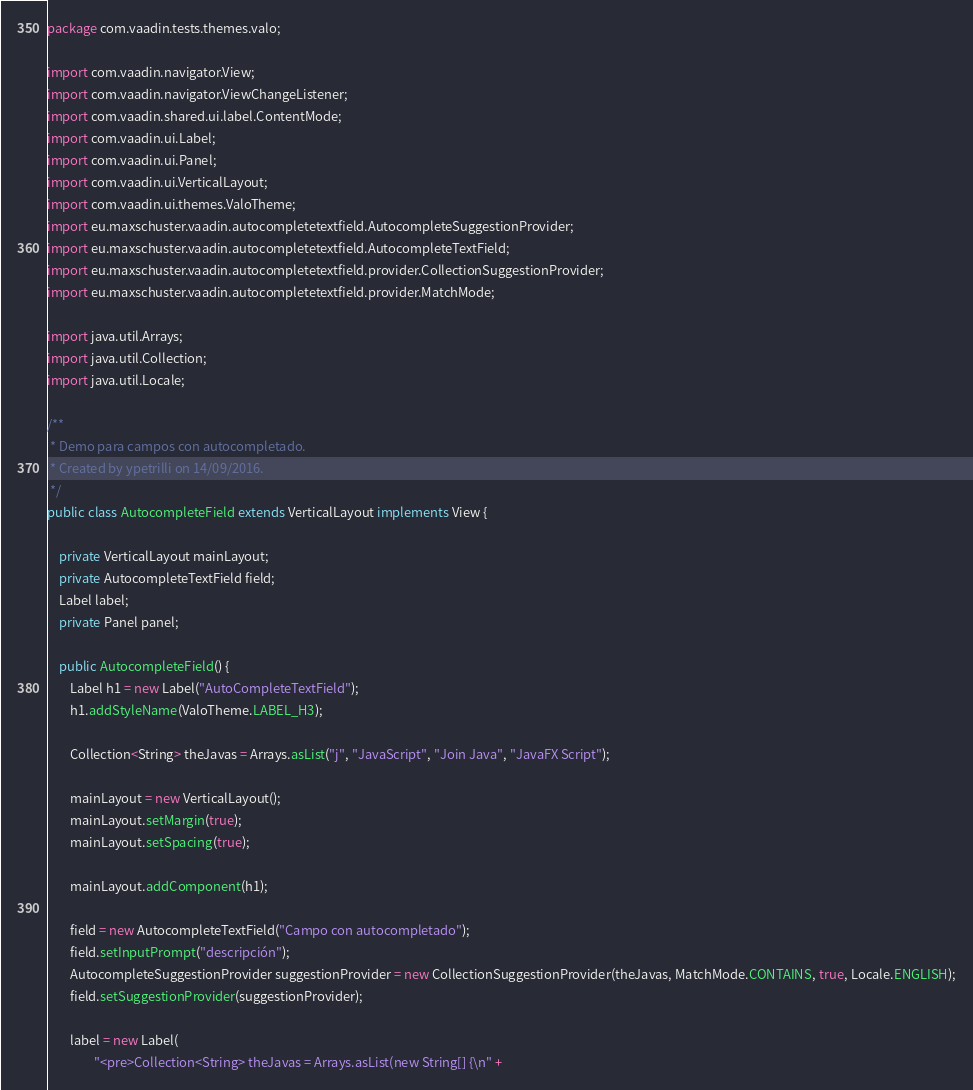Convert code to text. <code><loc_0><loc_0><loc_500><loc_500><_Java_>package com.vaadin.tests.themes.valo;

import com.vaadin.navigator.View;
import com.vaadin.navigator.ViewChangeListener;
import com.vaadin.shared.ui.label.ContentMode;
import com.vaadin.ui.Label;
import com.vaadin.ui.Panel;
import com.vaadin.ui.VerticalLayout;
import com.vaadin.ui.themes.ValoTheme;
import eu.maxschuster.vaadin.autocompletetextfield.AutocompleteSuggestionProvider;
import eu.maxschuster.vaadin.autocompletetextfield.AutocompleteTextField;
import eu.maxschuster.vaadin.autocompletetextfield.provider.CollectionSuggestionProvider;
import eu.maxschuster.vaadin.autocompletetextfield.provider.MatchMode;

import java.util.Arrays;
import java.util.Collection;
import java.util.Locale;

/**
 * Demo para campos con autocompletado.
 * Created by ypetrilli on 14/09/2016.
 */
public class AutocompleteField extends VerticalLayout implements View {

    private VerticalLayout mainLayout;
    private AutocompleteTextField field;
    Label label;
    private Panel panel;

    public AutocompleteField() {
        Label h1 = new Label("AutoCompleteTextField");
        h1.addStyleName(ValoTheme.LABEL_H3);

        Collection<String> theJavas = Arrays.asList("j", "JavaScript", "Join Java", "JavaFX Script");

        mainLayout = new VerticalLayout();
        mainLayout.setMargin(true);
        mainLayout.setSpacing(true);

        mainLayout.addComponent(h1);

        field = new AutocompleteTextField("Campo con autocompletado");
        field.setInputPrompt("descripción");
        AutocompleteSuggestionProvider suggestionProvider = new CollectionSuggestionProvider(theJavas, MatchMode.CONTAINS, true, Locale.ENGLISH);
        field.setSuggestionProvider(suggestionProvider);

        label = new Label(
                "<pre>Collection<String> theJavas = Arrays.asList(new String[] {\n" +</code> 